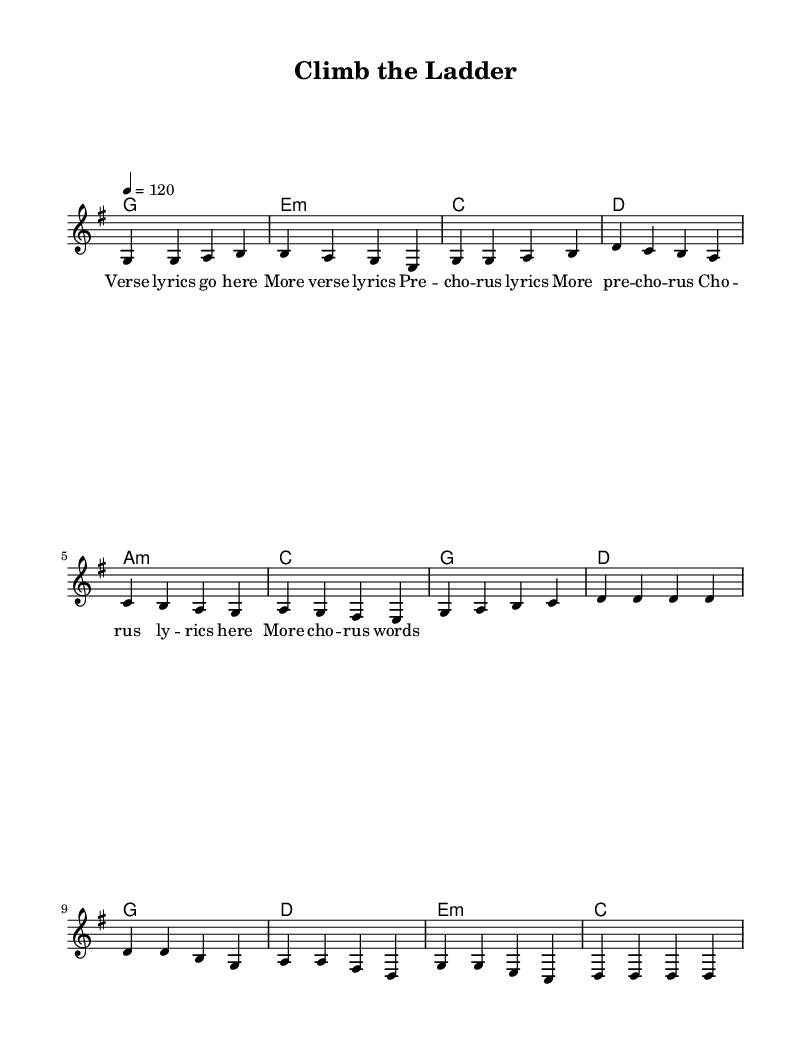What is the key signature of this music? The key signature is G major, which has one sharp (F#).
Answer: G major What is the time signature of this music? The time signature is 4/4, indicating four beats per measure.
Answer: 4/4 What is the tempo marking of the piece? The tempo marking indicates a speed of 120 beats per minute.
Answer: 120 How many measures are there in the chorus? The chorus consists of four measures as indicated by the musical notation.
Answer: 4 What is the first chord in the verse? The first chord in the verse is G major, represented by the symbol 'g'.
Answer: G What is the melodic interval between the first two notes of the melody? The first two notes are both G, which means there is no interval change.
Answer: Unison Which section contains the highest note? Analyzing the melody, the highest note in the piece appears in the chorus with D.
Answer: Chorus 